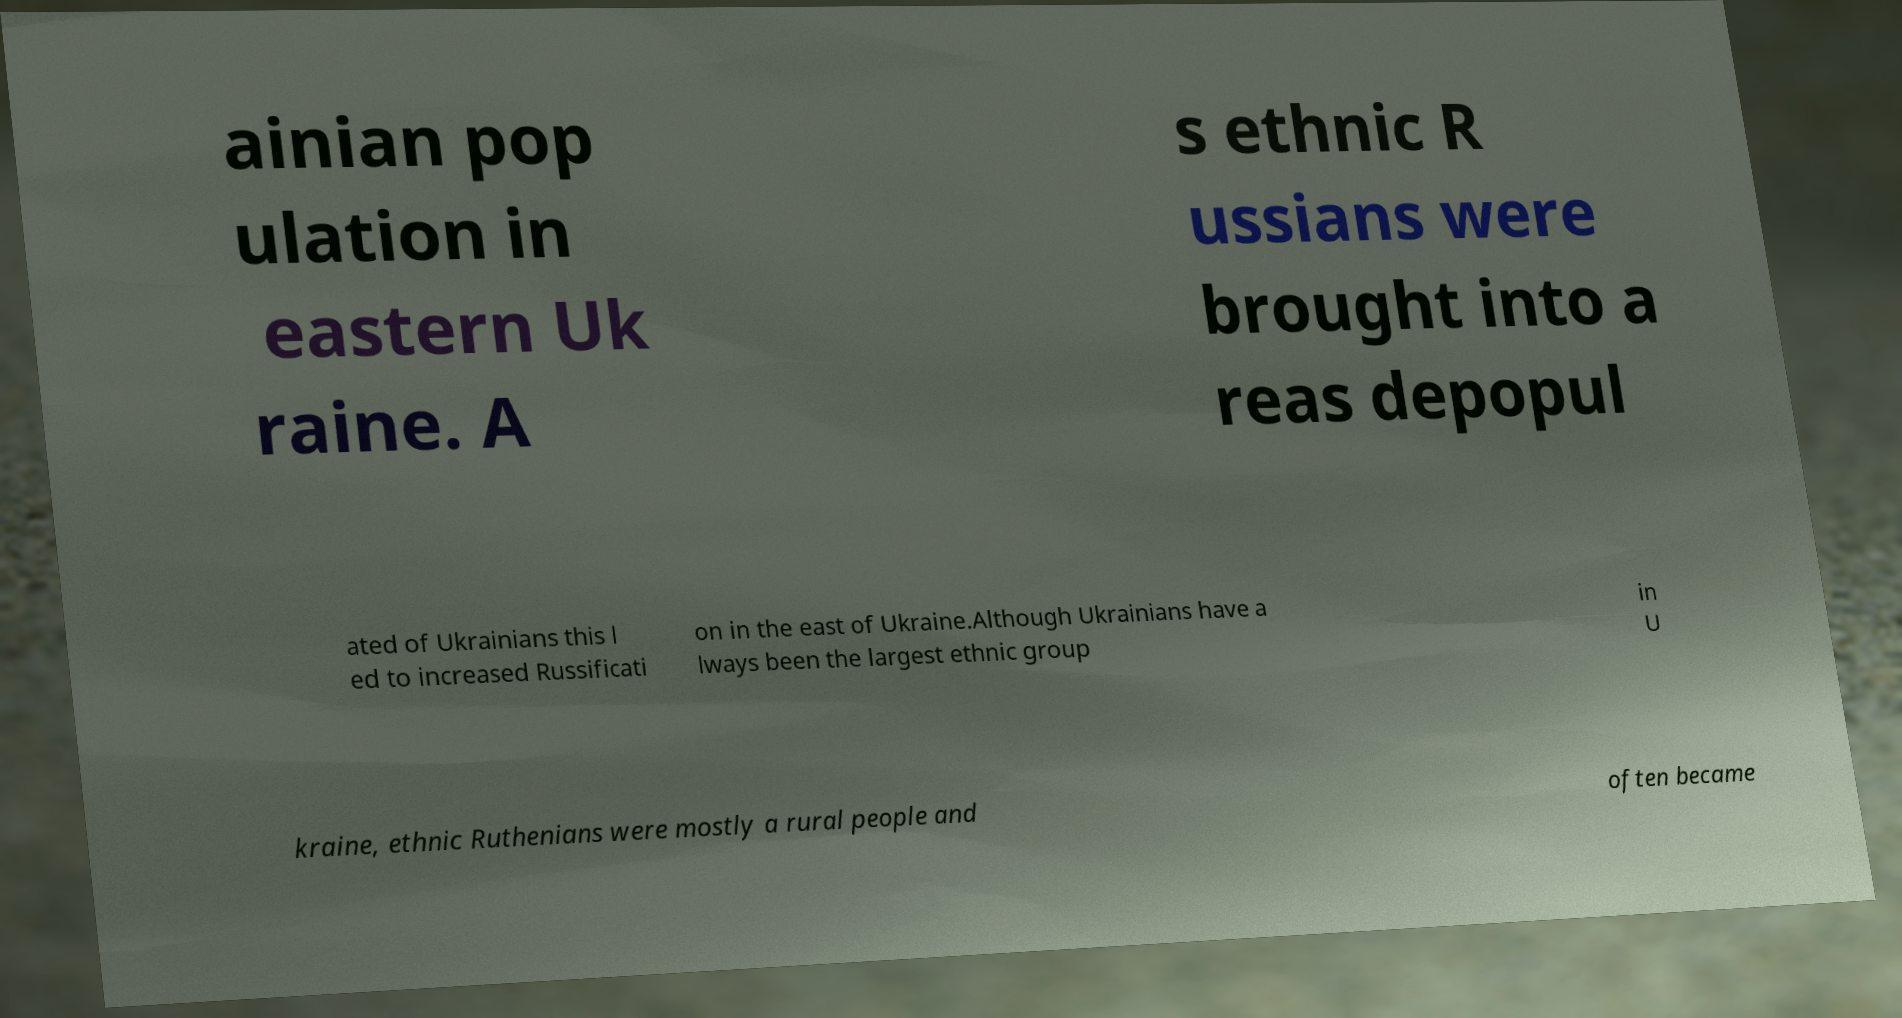Please identify and transcribe the text found in this image. ainian pop ulation in eastern Uk raine. A s ethnic R ussians were brought into a reas depopul ated of Ukrainians this l ed to increased Russificati on in the east of Ukraine.Although Ukrainians have a lways been the largest ethnic group in U kraine, ethnic Ruthenians were mostly a rural people and often became 